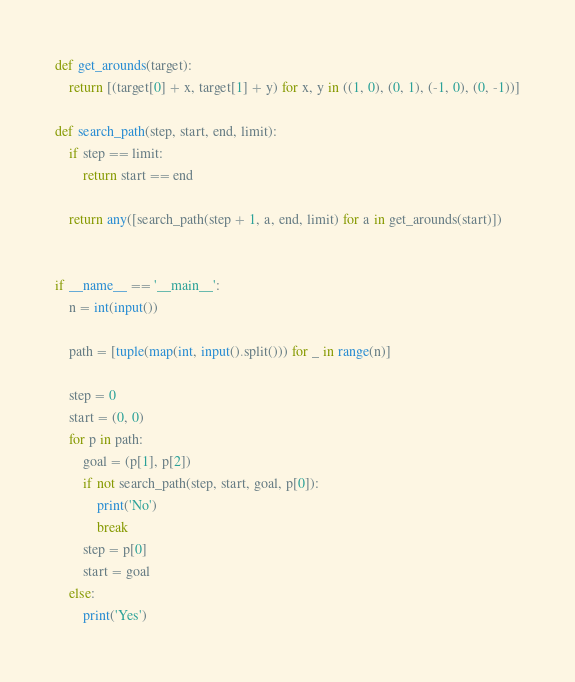Convert code to text. <code><loc_0><loc_0><loc_500><loc_500><_Python_>def get_arounds(target):
    return [(target[0] + x, target[1] + y) for x, y in ((1, 0), (0, 1), (-1, 0), (0, -1))]

def search_path(step, start, end, limit):
    if step == limit:
        return start == end

    return any([search_path(step + 1, a, end, limit) for a in get_arounds(start)])


if __name__ == '__main__':
    n = int(input())

    path = [tuple(map(int, input().split())) for _ in range(n)]

    step = 0
    start = (0, 0)
    for p in path:
        goal = (p[1], p[2])
        if not search_path(step, start, goal, p[0]):
            print('No')
            break
        step = p[0]
        start = goal
    else:
        print('Yes')
</code> 